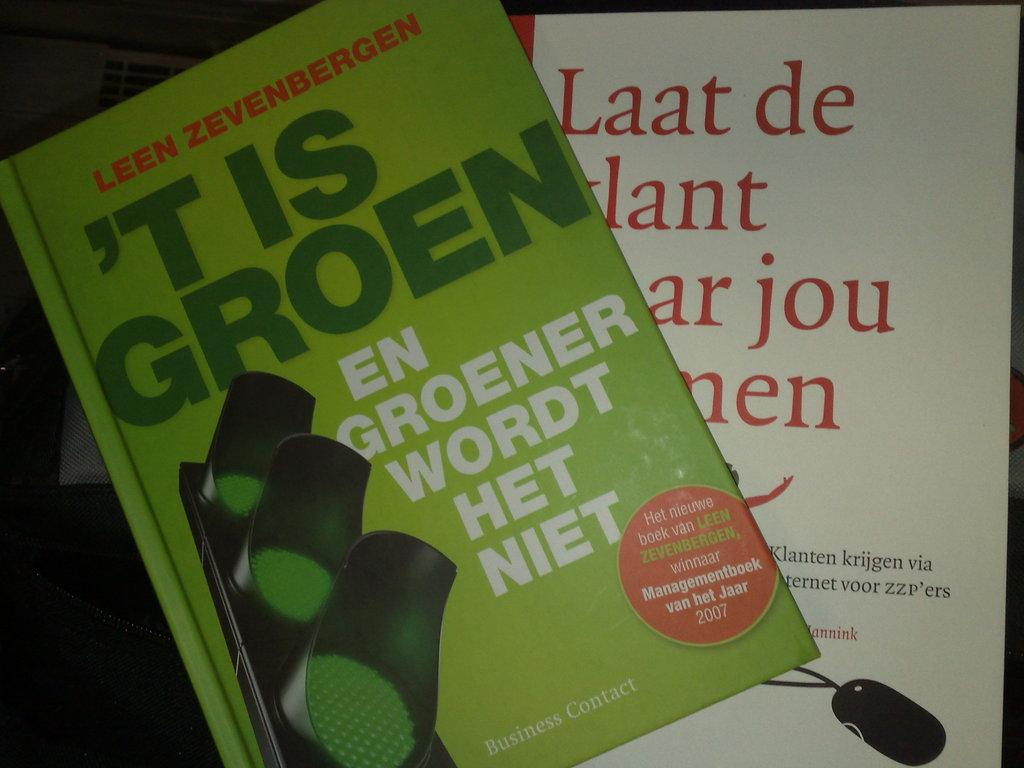<image>
Relay a brief, clear account of the picture shown. Green book by Leen Zevenbergen titled "'t Is Goren". 